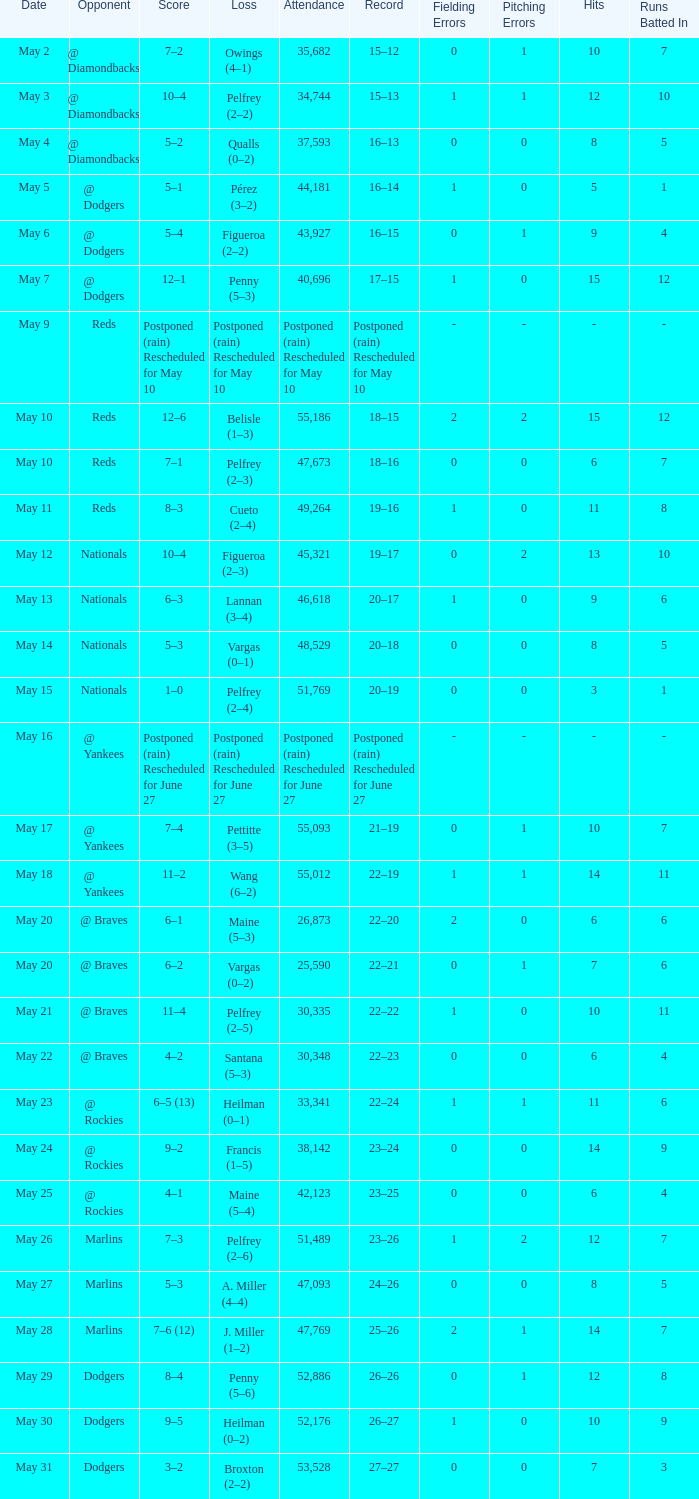Opponent of @ braves, and a Loss of pelfrey (2–5) had what score? 11–4. 